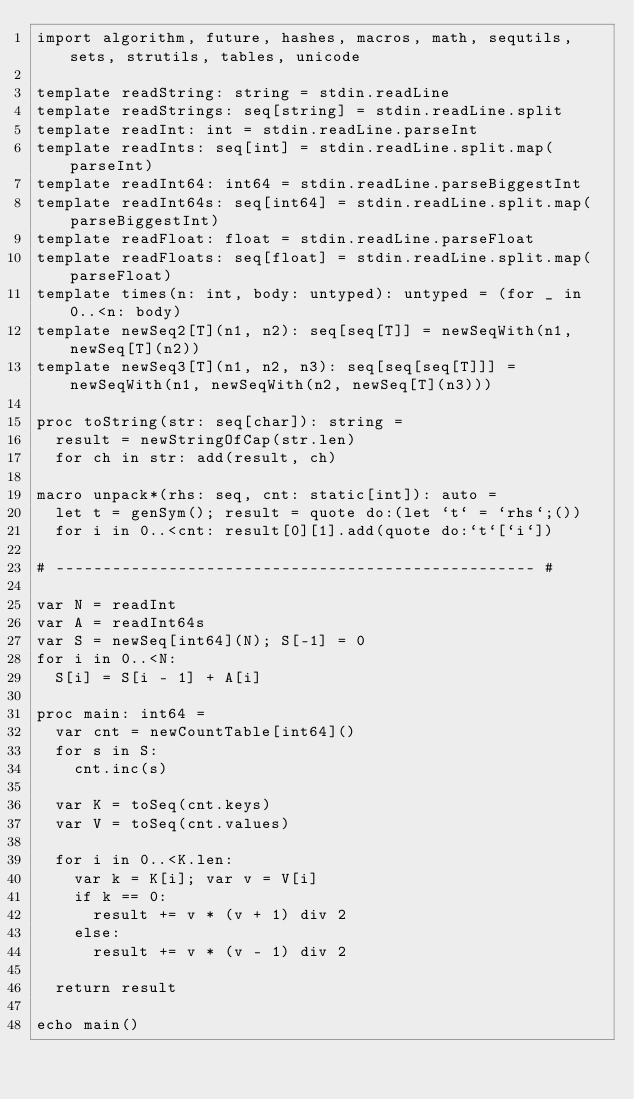<code> <loc_0><loc_0><loc_500><loc_500><_Nim_>import algorithm, future, hashes, macros, math, sequtils, sets, strutils, tables, unicode

template readString: string = stdin.readLine
template readStrings: seq[string] = stdin.readLine.split
template readInt: int = stdin.readLine.parseInt
template readInts: seq[int] = stdin.readLine.split.map(parseInt)
template readInt64: int64 = stdin.readLine.parseBiggestInt
template readInt64s: seq[int64] = stdin.readLine.split.map(parseBiggestInt)
template readFloat: float = stdin.readLine.parseFloat
template readFloats: seq[float] = stdin.readLine.split.map(parseFloat)
template times(n: int, body: untyped): untyped = (for _ in 0..<n: body)
template newSeq2[T](n1, n2): seq[seq[T]] = newSeqWith(n1, newSeq[T](n2))
template newSeq3[T](n1, n2, n3): seq[seq[seq[T]]] = newSeqWith(n1, newSeqWith(n2, newSeq[T](n3)))

proc toString(str: seq[char]): string =
  result = newStringOfCap(str.len)
  for ch in str: add(result, ch)

macro unpack*(rhs: seq, cnt: static[int]): auto =
  let t = genSym(); result = quote do:(let `t` = `rhs`;())
  for i in 0..<cnt: result[0][1].add(quote do:`t`[`i`])

# --------------------------------------------------- #

var N = readInt
var A = readInt64s
var S = newSeq[int64](N); S[-1] = 0
for i in 0..<N:
  S[i] = S[i - 1] + A[i]

proc main: int64 =
  var cnt = newCountTable[int64]()
  for s in S:
    cnt.inc(s)

  var K = toSeq(cnt.keys)
  var V = toSeq(cnt.values)
  
  for i in 0..<K.len:
    var k = K[i]; var v = V[i]
    if k == 0:
      result += v * (v + 1) div 2
    else:
      result += v * (v - 1) div 2

  return result

echo main()</code> 